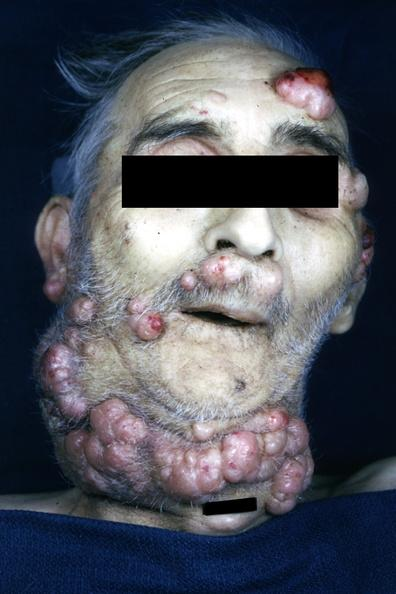what is present?
Answer the question using a single word or phrase. Multiple myeloma 